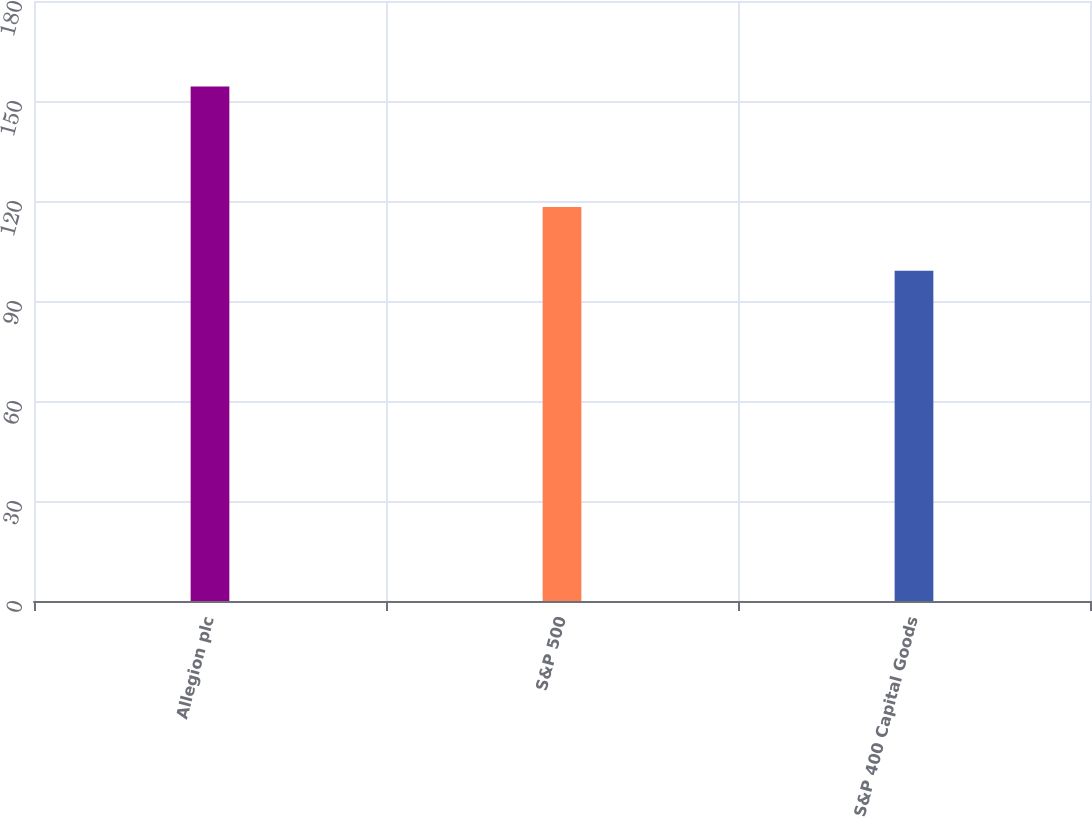<chart> <loc_0><loc_0><loc_500><loc_500><bar_chart><fcel>Allegion plc<fcel>S&P 500<fcel>S&P 400 Capital Goods<nl><fcel>154.37<fcel>118.18<fcel>99.07<nl></chart> 